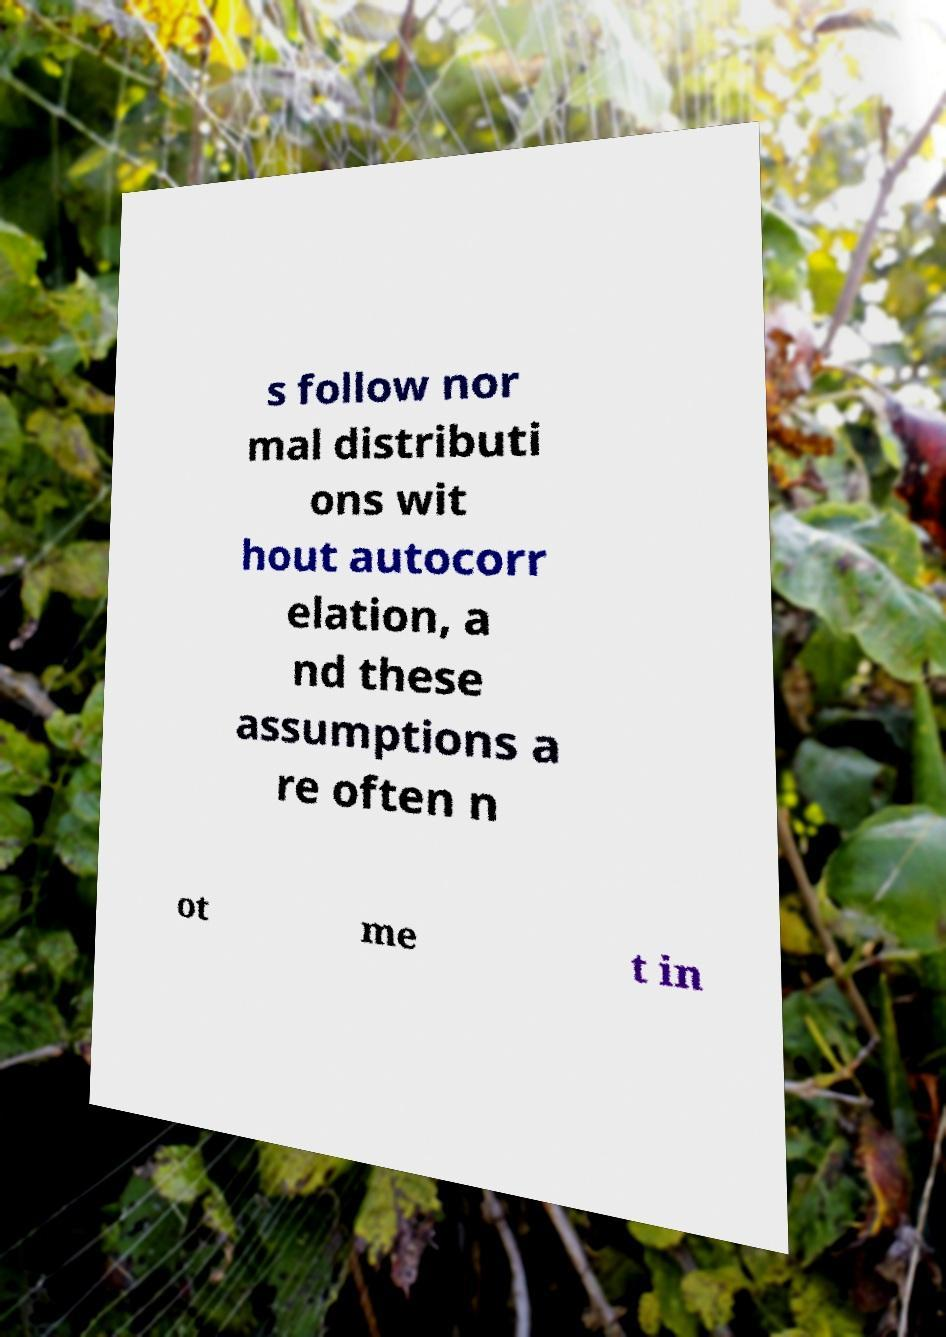What messages or text are displayed in this image? I need them in a readable, typed format. s follow nor mal distributi ons wit hout autocorr elation, a nd these assumptions a re often n ot me t in 